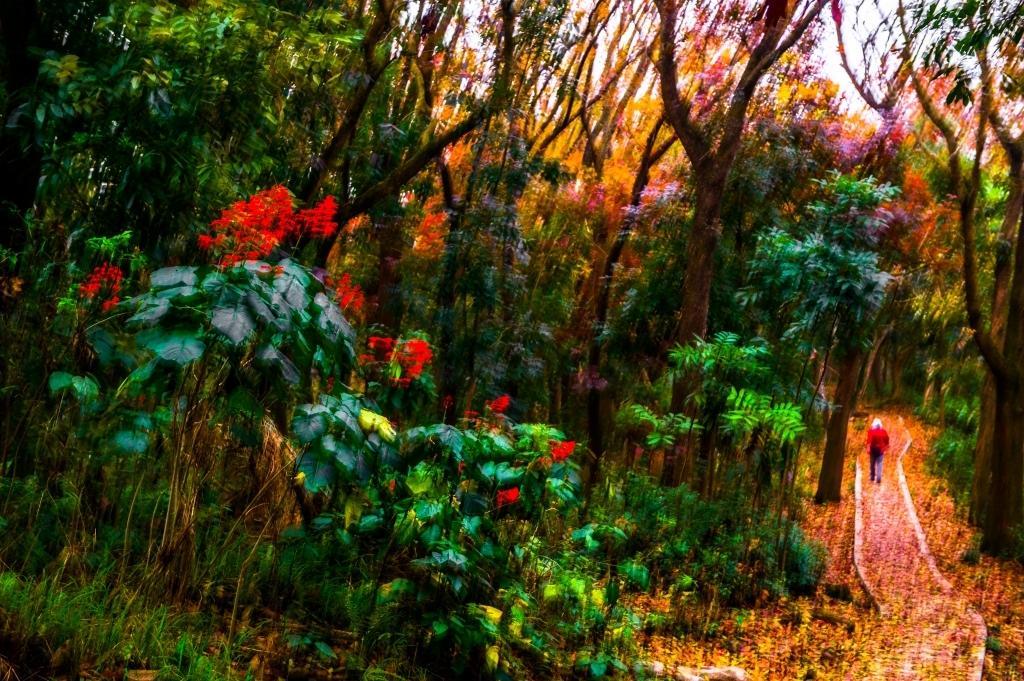Please provide a concise description of this image. This image is slightly blurred, where we can see plants, a person walking on the way, dry leaves, trees and the sky in the background. 